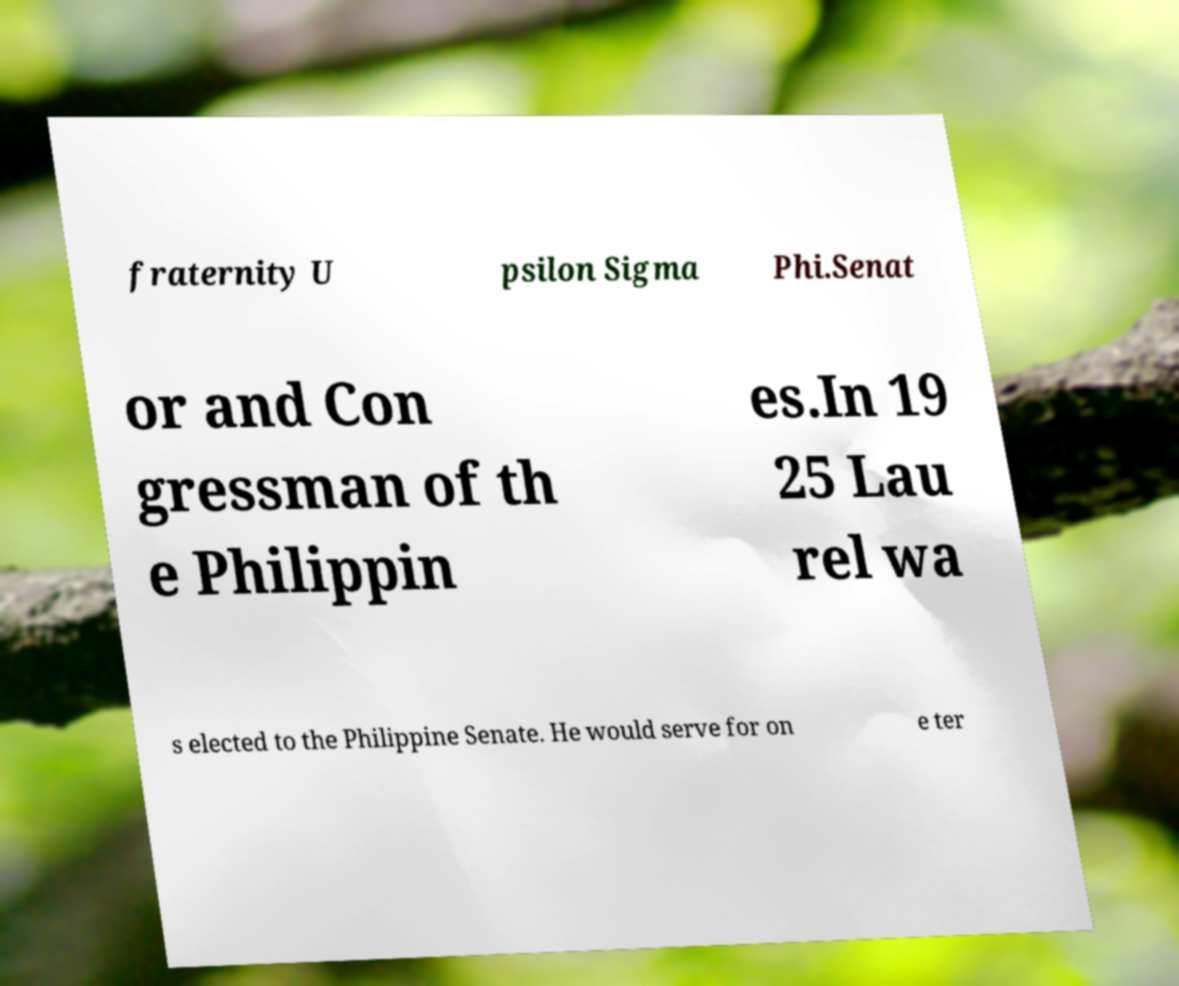For documentation purposes, I need the text within this image transcribed. Could you provide that? fraternity U psilon Sigma Phi.Senat or and Con gressman of th e Philippin es.In 19 25 Lau rel wa s elected to the Philippine Senate. He would serve for on e ter 